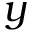<formula> <loc_0><loc_0><loc_500><loc_500>y</formula> 